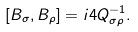<formula> <loc_0><loc_0><loc_500><loc_500>[ B _ { \sigma } , B _ { \rho } ] = i 4 Q ^ { - 1 } _ { \sigma \rho } .</formula> 